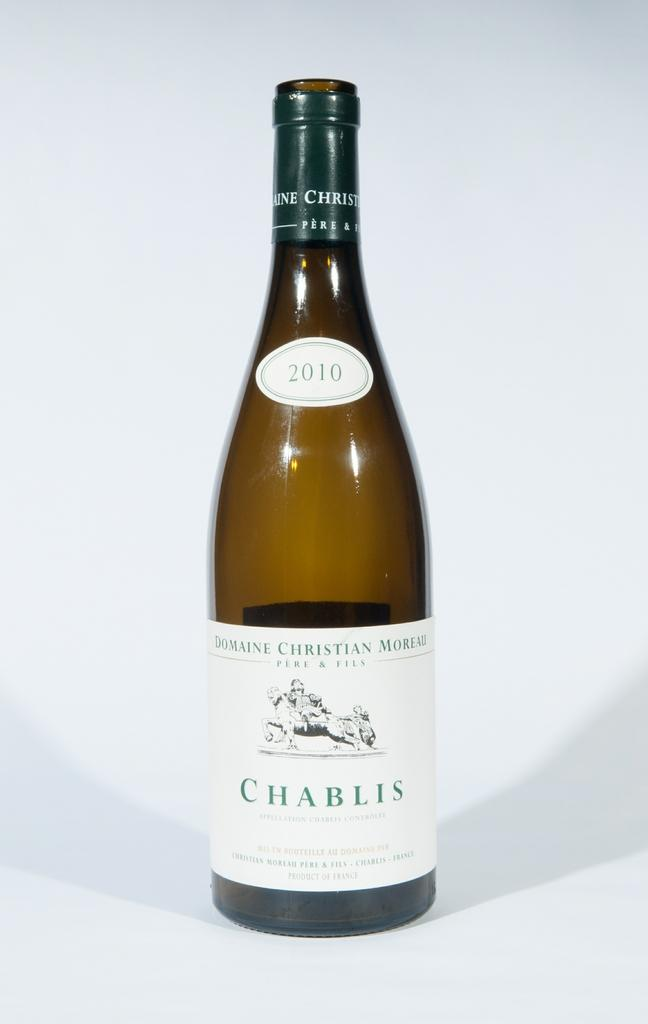<image>
Summarize the visual content of the image. A bottle of white wine named CHABLIS placed against white background. 